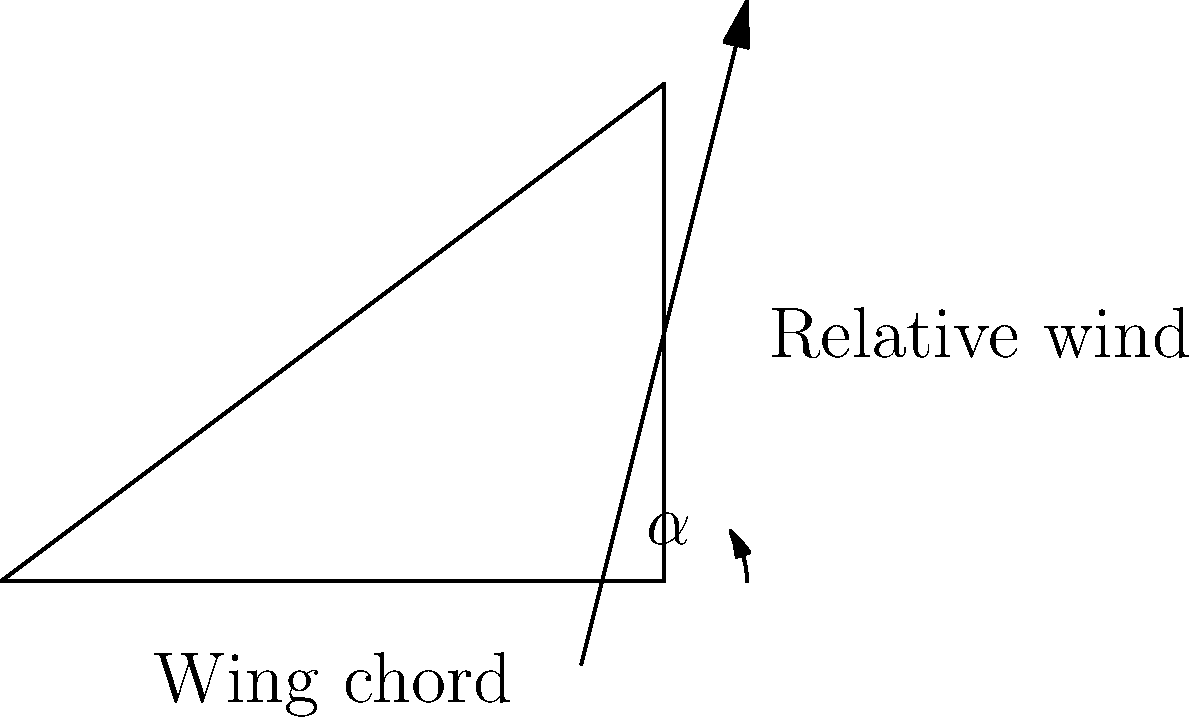In the diagram, a simplified pterosaur wing is represented by the triangle ABC. The base of the triangle (AB) represents the wing chord, and the arrow indicates the direction of relative wind. If the wing chord is 4 meters long and the height of the triangle (BC) is 3 meters, what is the angle of attack ($\alpha$) in degrees? To find the angle of attack ($\alpha$), we need to follow these steps:

1. Identify the right triangle formed by the wing chord and the height.
2. Use the arctangent function to calculate the angle.

Let's proceed step-by-step:

1. We have a right triangle where:
   - The base (wing chord) is 4 meters
   - The height is 3 meters

2. The angle of attack is the angle between the wing chord and the relative wind.
   This is the same as the angle between the base of the triangle and its hypotenuse.

3. We can calculate this angle using the arctangent function:

   $\alpha = \arctan(\frac{\text{opposite}}{\text{adjacent}}) = \arctan(\frac{\text{height}}{\text{base}})$

4. Plugging in our values:

   $\alpha = \arctan(\frac{3}{4})$

5. Using a calculator or mathematical software:

   $\alpha \approx 36.87°$

6. Rounding to the nearest degree:

   $\alpha \approx 37°$

Thus, the angle of attack for the pterosaur wing in this configuration is approximately 37 degrees.
Answer: 37° 